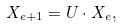Convert formula to latex. <formula><loc_0><loc_0><loc_500><loc_500>X _ { e + 1 } = U \cdot X _ { e } ,</formula> 